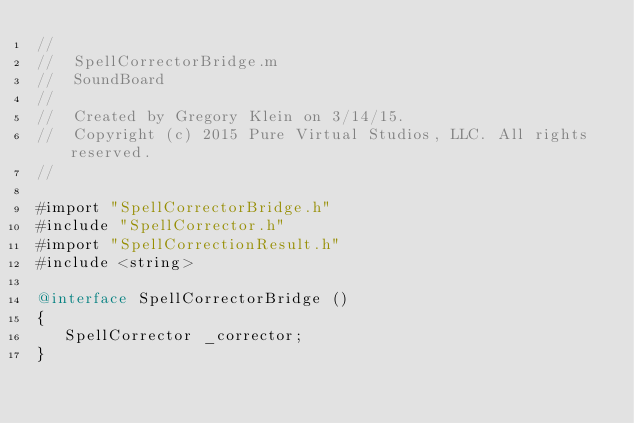Convert code to text. <code><loc_0><loc_0><loc_500><loc_500><_ObjectiveC_>//
//  SpellCorrectorBridge.m
//  SoundBoard
//
//  Created by Gregory Klein on 3/14/15.
//  Copyright (c) 2015 Pure Virtual Studios, LLC. All rights reserved.
//

#import "SpellCorrectorBridge.h"
#include "SpellCorrector.h"
#import "SpellCorrectionResult.h"
#include <string>

@interface SpellCorrectorBridge ()
{
   SpellCorrector _corrector;
}
</code> 